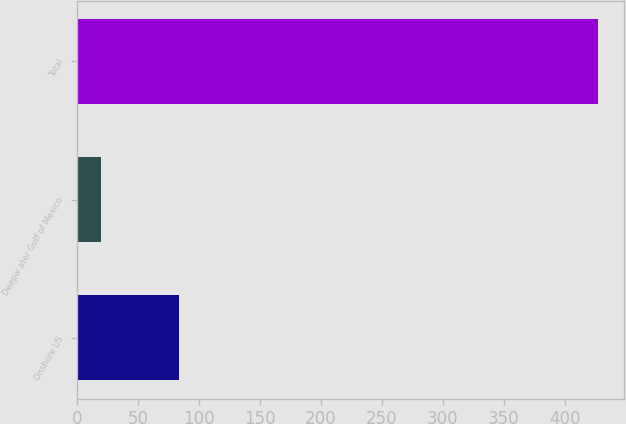Convert chart to OTSL. <chart><loc_0><loc_0><loc_500><loc_500><bar_chart><fcel>Onshore US<fcel>Deepw ater Gulf of Mexico<fcel>Total<nl><fcel>84<fcel>20<fcel>427<nl></chart> 